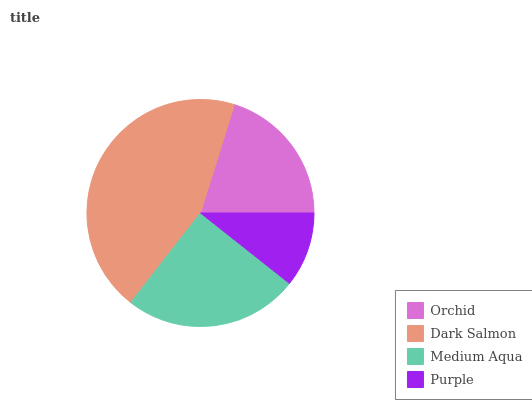Is Purple the minimum?
Answer yes or no. Yes. Is Dark Salmon the maximum?
Answer yes or no. Yes. Is Medium Aqua the minimum?
Answer yes or no. No. Is Medium Aqua the maximum?
Answer yes or no. No. Is Dark Salmon greater than Medium Aqua?
Answer yes or no. Yes. Is Medium Aqua less than Dark Salmon?
Answer yes or no. Yes. Is Medium Aqua greater than Dark Salmon?
Answer yes or no. No. Is Dark Salmon less than Medium Aqua?
Answer yes or no. No. Is Medium Aqua the high median?
Answer yes or no. Yes. Is Orchid the low median?
Answer yes or no. Yes. Is Purple the high median?
Answer yes or no. No. Is Purple the low median?
Answer yes or no. No. 